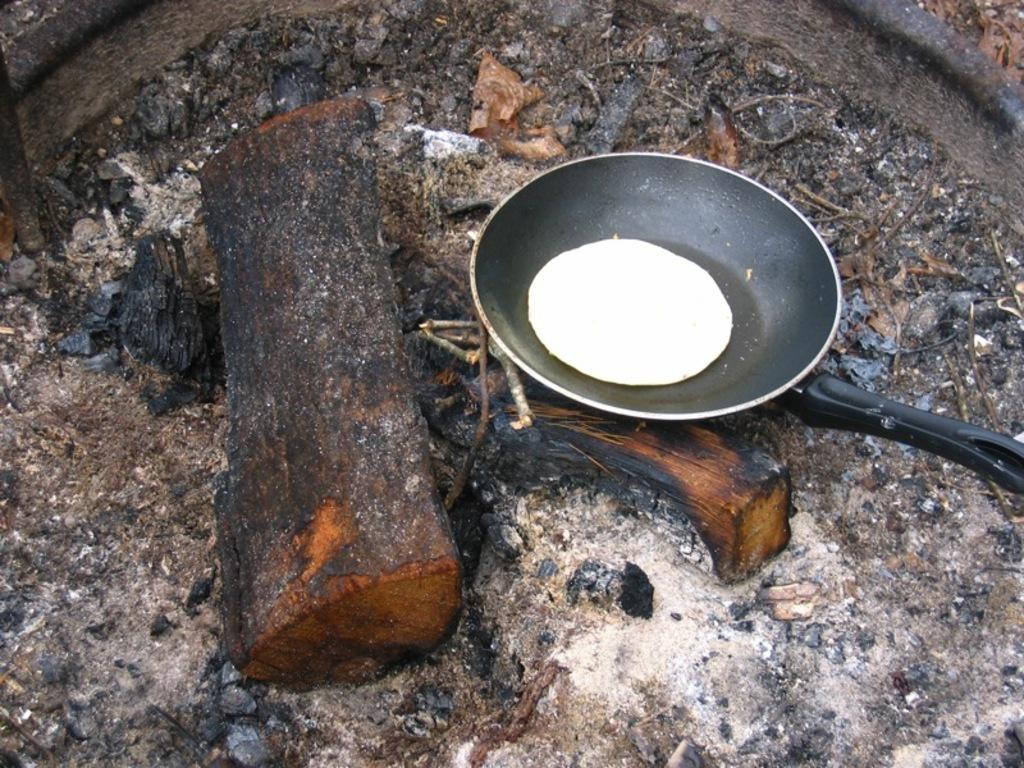What is in the pan that is visible in the image? There is a food item in the pan in the image. What other items can be seen in the image besides the pan? There are wooden logs and sticks visible in the image. Where are all the elements placed in the image? All the elements are placed on the ground in the image. What type of government is being protested in the image? There is no protest or government present in the image; it features a pan with a food item, wooden logs, and sticks placed on the ground. 